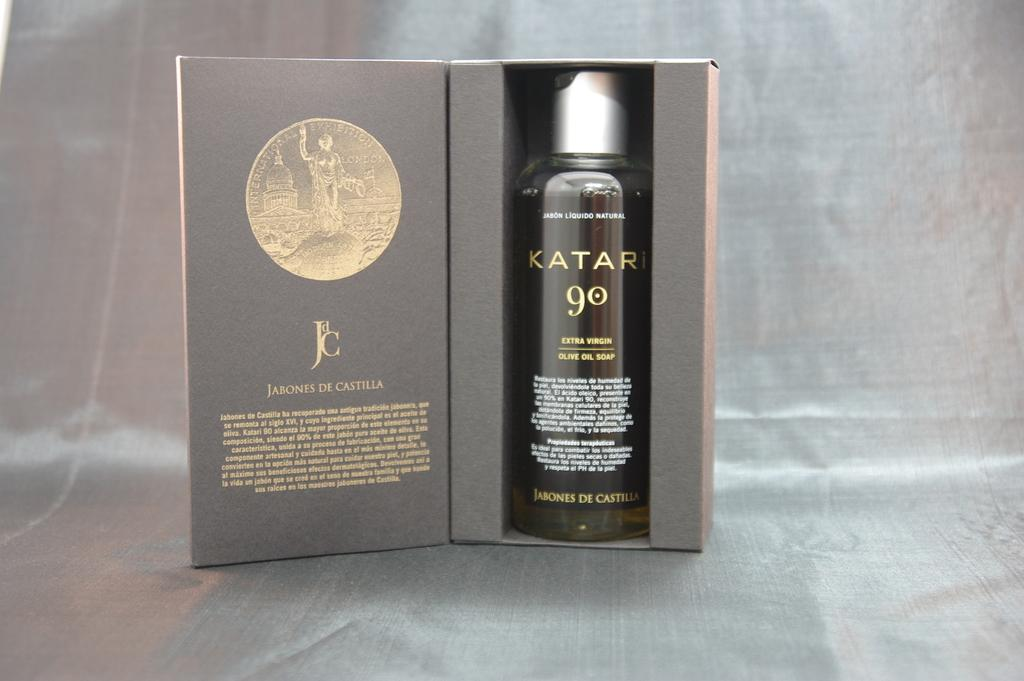What object is on the table in the image? There is a bottle on the table in the image. How is the bottle positioned in the image? The bottle is in a box in the image. What color is the bottle? The bottle is black in color. Is there any additional information attached to the bottle? Yes, there is a card attached to the bottle. What type of debt is associated with the bottle in the image? There is no mention of debt in the image; it only features a bottle in a box with a black color and a card attached to it. How many leaves are visible on the bottle in the image? There are no leaves present on the bottle in the image. 